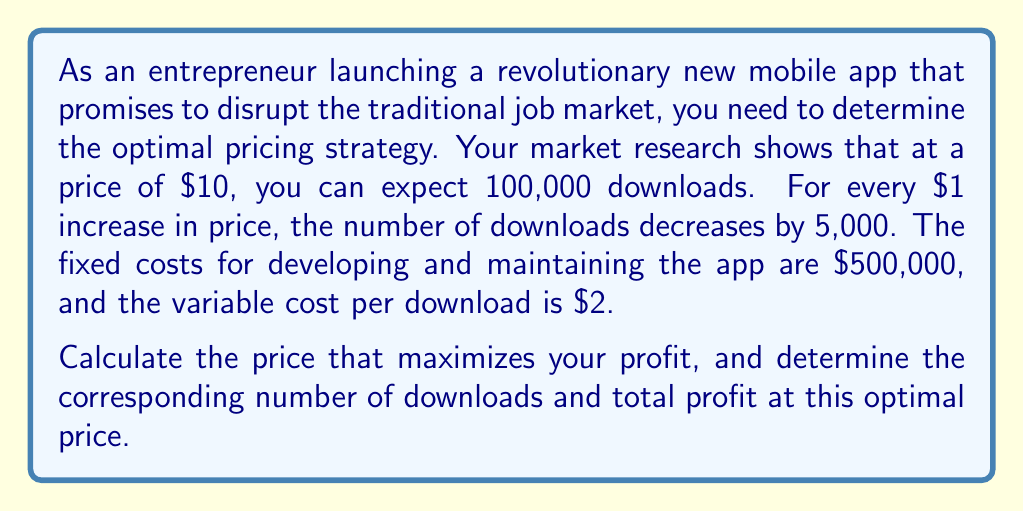Could you help me with this problem? Let's approach this step-by-step:

1) First, let's define our variables:
   $p$ = price per download
   $q$ = number of downloads
   $FC$ = fixed costs
   $VC$ = variable cost per download

2) We can express $q$ as a function of $p$:
   $q = 100,000 - 5,000(p - 10)$
   $q = 150,000 - 5,000p$

3) The total revenue (TR) function is:
   $TR = pq = p(150,000 - 5,000p) = 150,000p - 5,000p^2$

4) The total cost (TC) function is:
   $TC = FC + VC \cdot q = 500,000 + 2(150,000 - 5,000p) = 800,000 - 10,000p$

5) The profit function (П) is:
   $П = TR - TC = (150,000p - 5,000p^2) - (800,000 - 10,000p)$
   $П = -5,000p^2 + 160,000p - 800,000$

6) To find the maximum profit, we differentiate П with respect to p and set it to zero:
   $\frac{dП}{dp} = -10,000p + 160,000 = 0$
   $10,000p = 160,000$
   $p = 16$

7) The second derivative is negative ($-10,000$), confirming this is a maximum.

8) At $p = 16$, the number of downloads is:
   $q = 150,000 - 5,000(16) = 70,000$

9) The maximum profit is:
   $П = -5,000(16)^2 + 160,000(16) - 800,000 = 480,000$
Answer: The optimal price is $16 per download. At this price, there will be 70,000 downloads, resulting in a maximum profit of $480,000. 